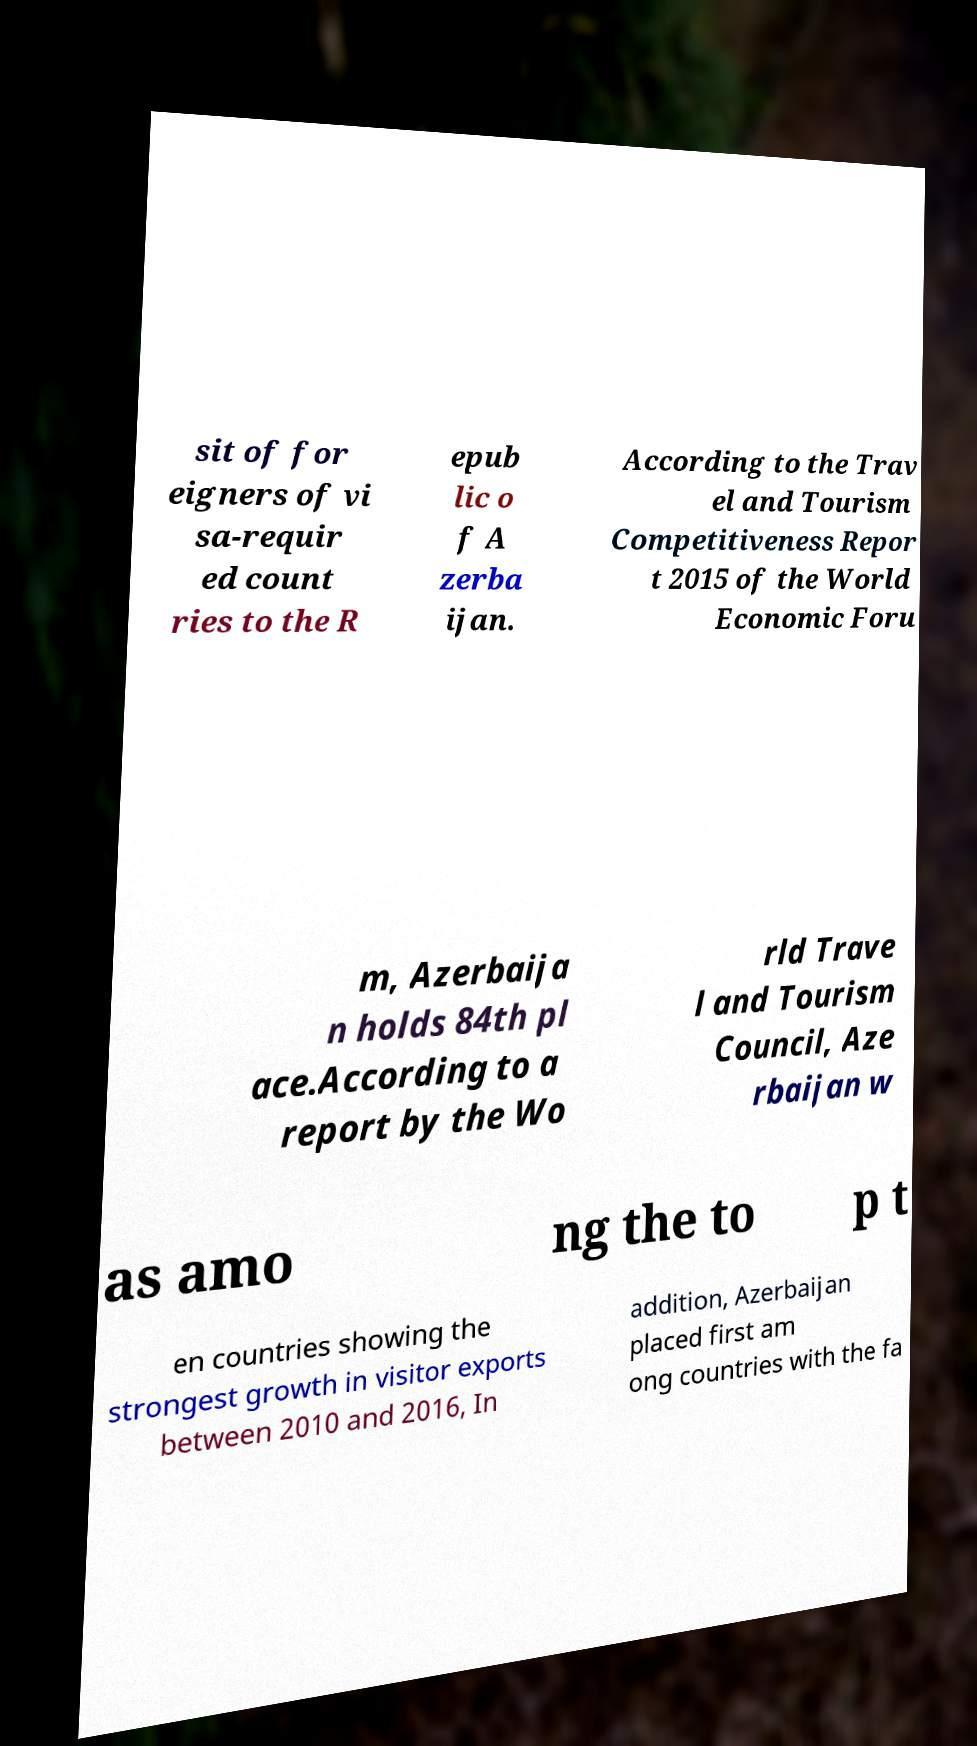Can you accurately transcribe the text from the provided image for me? sit of for eigners of vi sa-requir ed count ries to the R epub lic o f A zerba ijan. According to the Trav el and Tourism Competitiveness Repor t 2015 of the World Economic Foru m, Azerbaija n holds 84th pl ace.According to a report by the Wo rld Trave l and Tourism Council, Aze rbaijan w as amo ng the to p t en countries showing the strongest growth in visitor exports between 2010 and 2016, In addition, Azerbaijan placed first am ong countries with the fa 